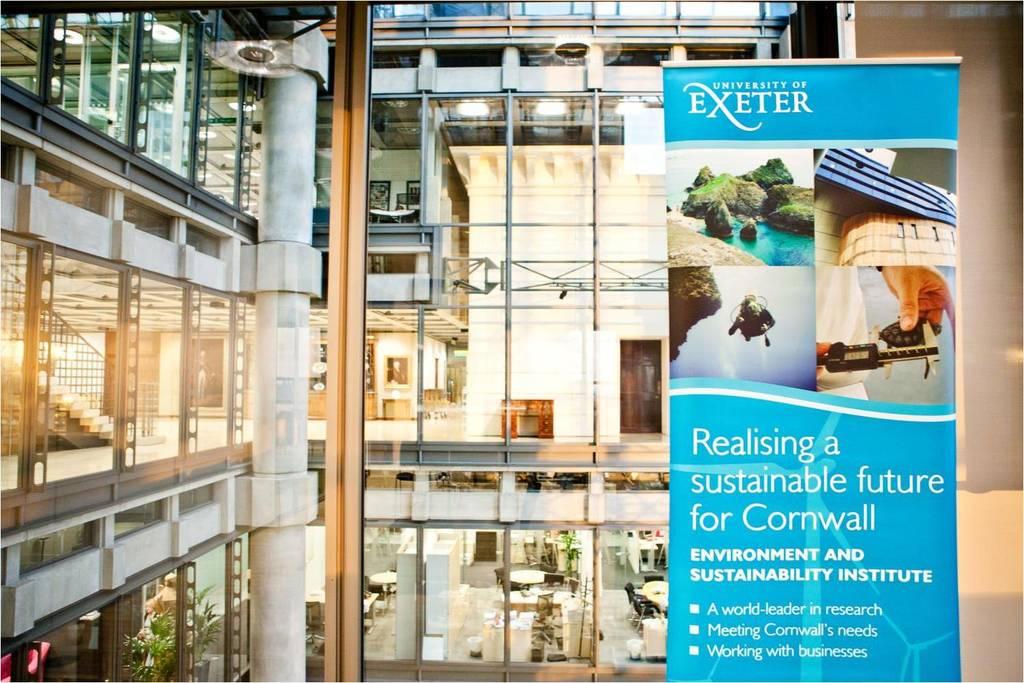What brand is at the top of the banner?
Ensure brevity in your answer.  Exeter. 